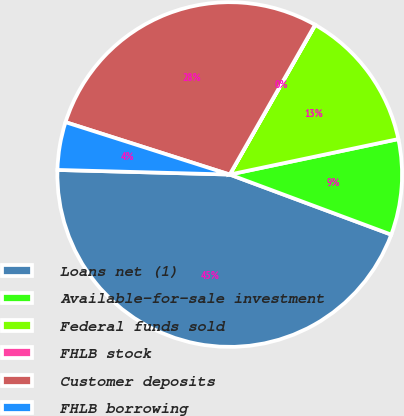Convert chart to OTSL. <chart><loc_0><loc_0><loc_500><loc_500><pie_chart><fcel>Loans net (1)<fcel>Available-for-sale investment<fcel>Federal funds sold<fcel>FHLB stock<fcel>Customer deposits<fcel>FHLB borrowing<nl><fcel>44.76%<fcel>8.97%<fcel>13.44%<fcel>0.02%<fcel>28.33%<fcel>4.49%<nl></chart> 